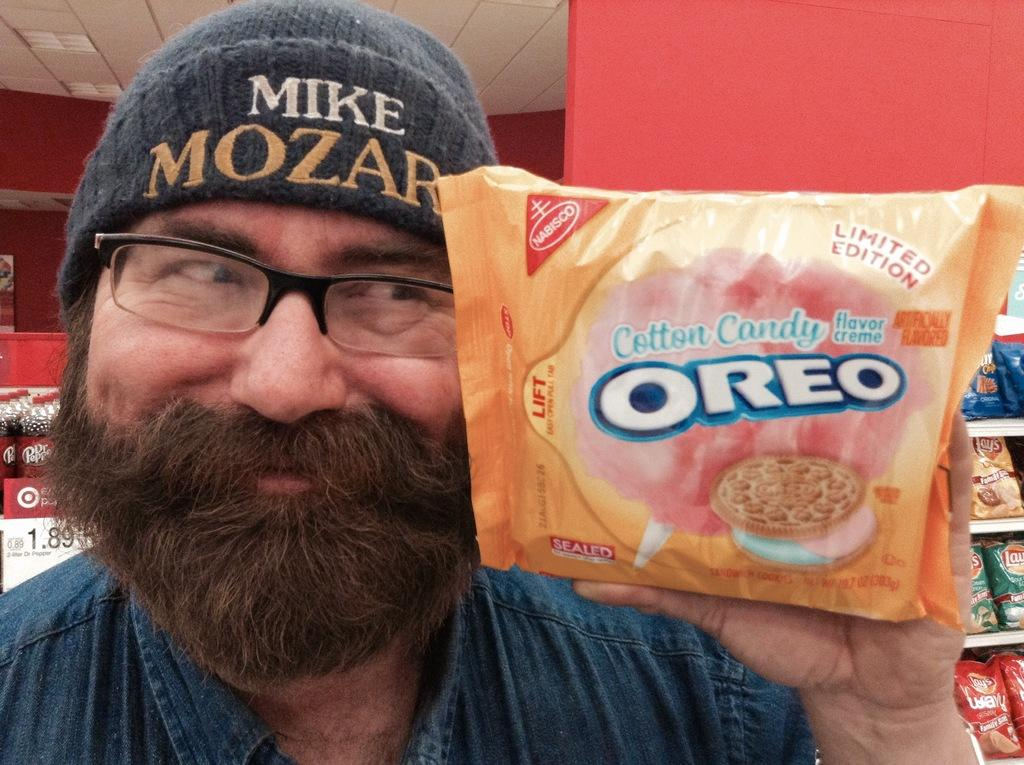What is the person in the image doing? The person is standing in the image. What is the person holding in the image? The person is holding a biscuit packet. What can be seen in the background of the image? There are food packets displayed in the background of the image. What type of underwear is the person wearing in the image? There is no information about the person's underwear in the image, so it cannot be determined. Can you tell me how many turkeys are visible in the image? There are no turkeys present in the image. What type of drug can be seen in the image? There is no drug present in the image. 